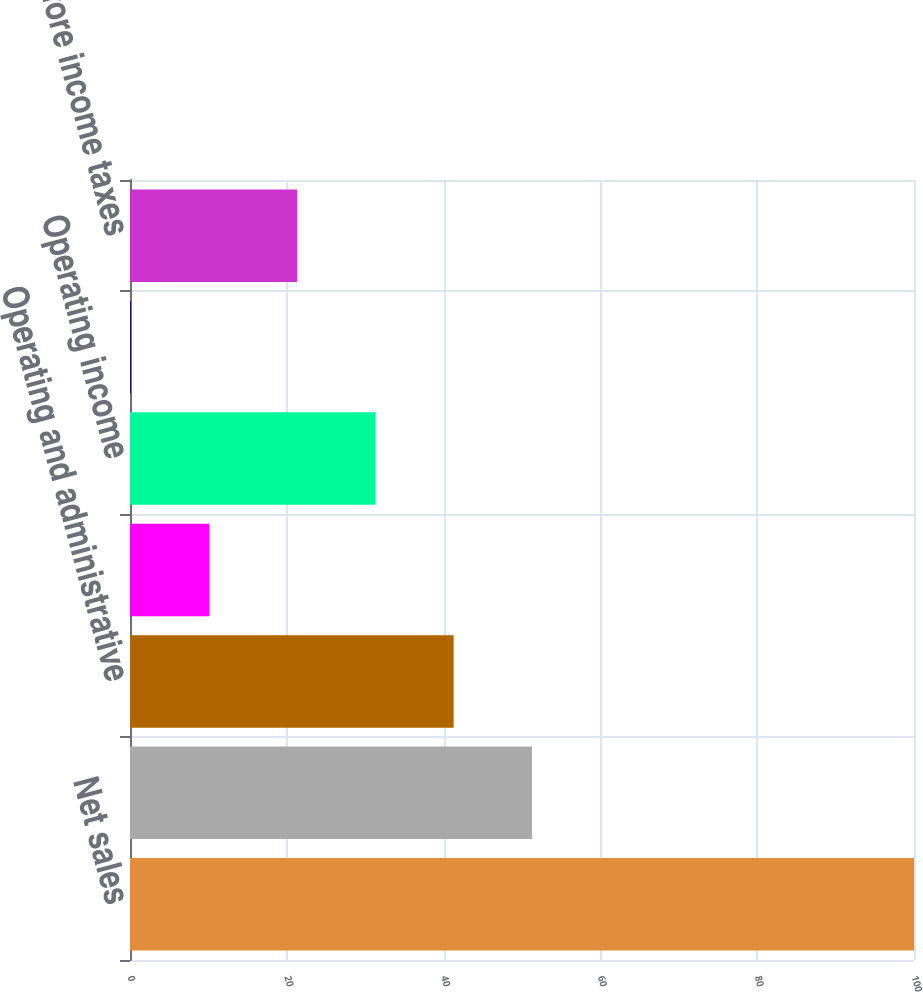<chart> <loc_0><loc_0><loc_500><loc_500><bar_chart><fcel>Net sales<fcel>Gross profit<fcel>Operating and administrative<fcel>Gain on sale of property and<fcel>Operating income<fcel>Net interest income (expense)<fcel>Earnings before income taxes<nl><fcel>100<fcel>51.27<fcel>41.28<fcel>10.09<fcel>31.29<fcel>0.1<fcel>21.3<nl></chart> 